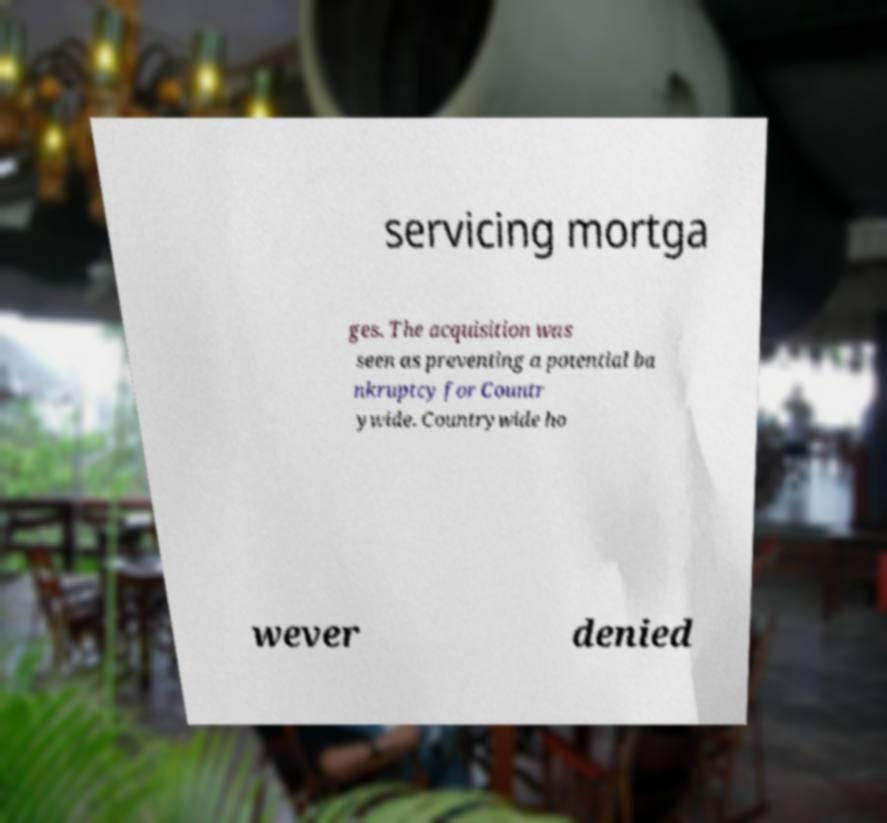I need the written content from this picture converted into text. Can you do that? servicing mortga ges. The acquisition was seen as preventing a potential ba nkruptcy for Countr ywide. Countrywide ho wever denied 